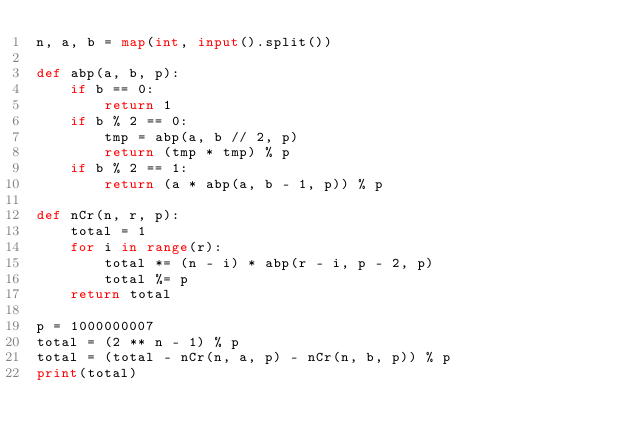<code> <loc_0><loc_0><loc_500><loc_500><_Python_>n, a, b = map(int, input().split())

def abp(a, b, p):
    if b == 0:
        return 1
    if b % 2 == 0:
        tmp = abp(a, b // 2, p)
        return (tmp * tmp) % p
    if b % 2 == 1:
        return (a * abp(a, b - 1, p)) % p
 
def nCr(n, r, p):
    total = 1
    for i in range(r):
        total *= (n - i) * abp(r - i, p - 2, p)
        total %= p
    return total

p = 1000000007
total = (2 ** n - 1) % p
total = (total - nCr(n, a, p) - nCr(n, b, p)) % p
print(total)</code> 